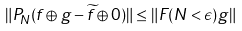Convert formula to latex. <formula><loc_0><loc_0><loc_500><loc_500>\| P _ { N } ( f \oplus g - \widetilde { f } \oplus 0 ) \| \leq \| F ( N < \epsilon ) g \|</formula> 